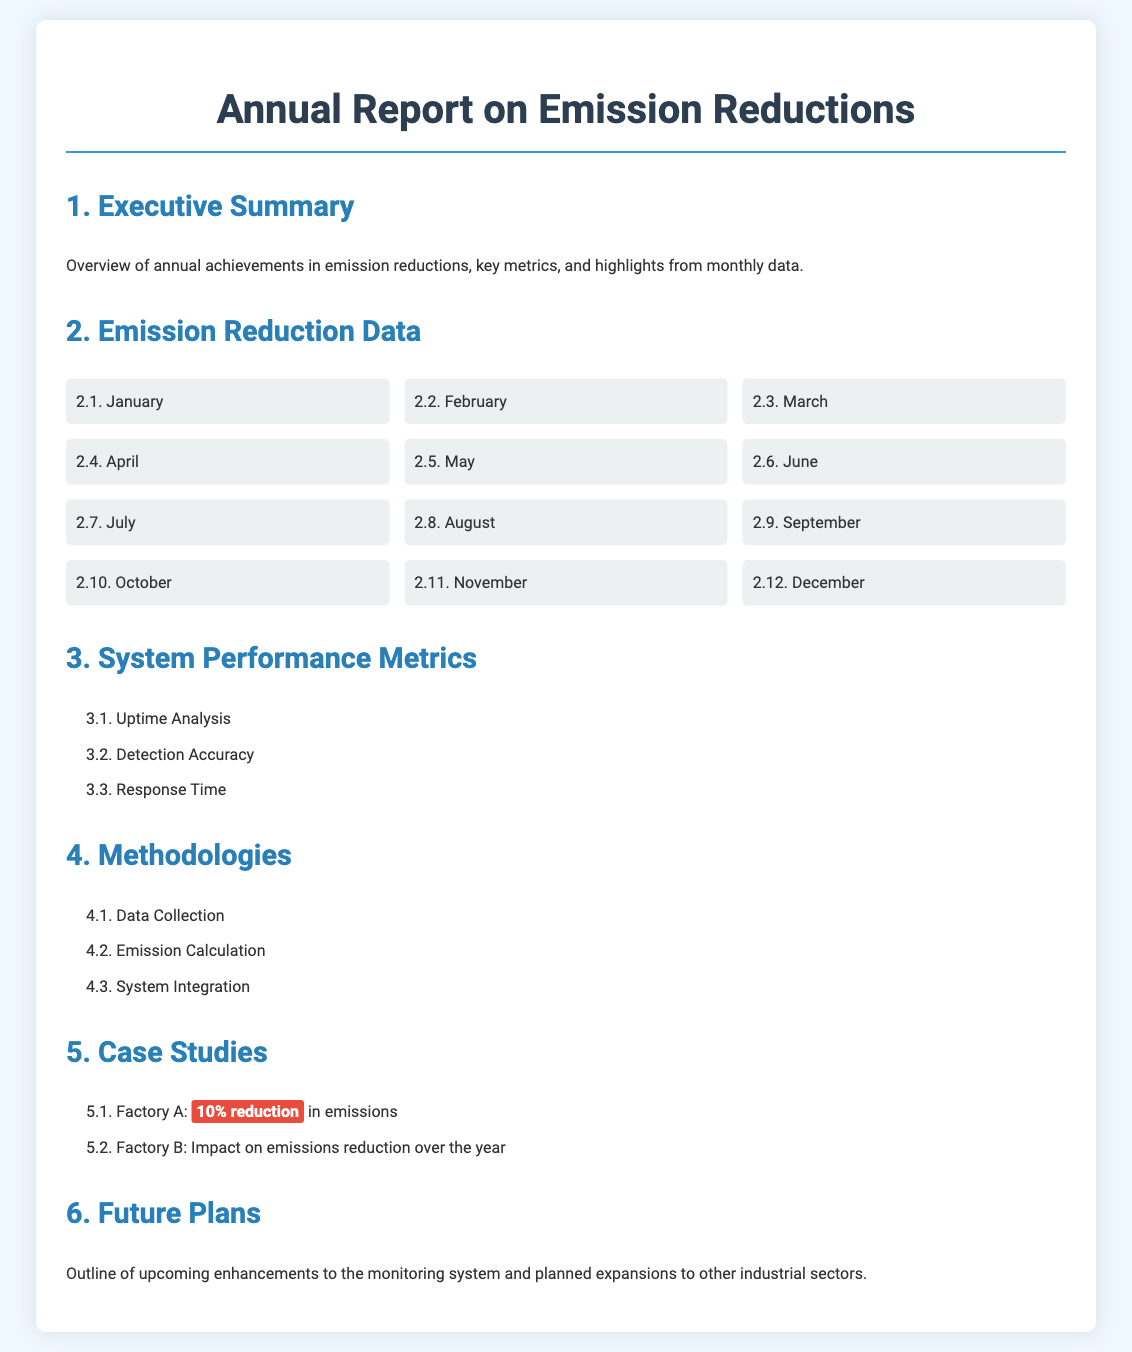What is the title of the report? The title of the report is given in the document header, which outlines the main focus of the content.
Answer: Annual Report on Emission Reductions How many months of emission reduction data are included? The document lists monthly data breakdowns, indicating the number of months represented.
Answer: 12 What was the emission reduction percentage for Factory A? The document explicitly states the reduction percentage for Factory A in the case studies section.
Answer: 10% What is included in the System Performance Metrics section? This section lists multiple performance metrics related to the monitoring system's functionality.
Answer: Uptime Analysis, Detection Accuracy, Response Time What future plans are mentioned in the report? The document briefly mentions the content about the upcoming enhancements related to emissions monitoring plans.
Answer: Enhancements to the monitoring system What does the Executive Summary section provide? The Executive Summary section outlines key achievements and metrics, summarizing the results over the year.
Answer: Overview of annual achievements in emission reductions Which factory's emissions reduction impact is specifically mentioned? The text highlights Factory B's impact, indicating it is noteworthy within the case studies.
Answer: Factory B What design style is used for the month data breakdowns? The layout and formatting style of the month data breakdown section is indicated in the design section of the code.
Answer: Grid layout 